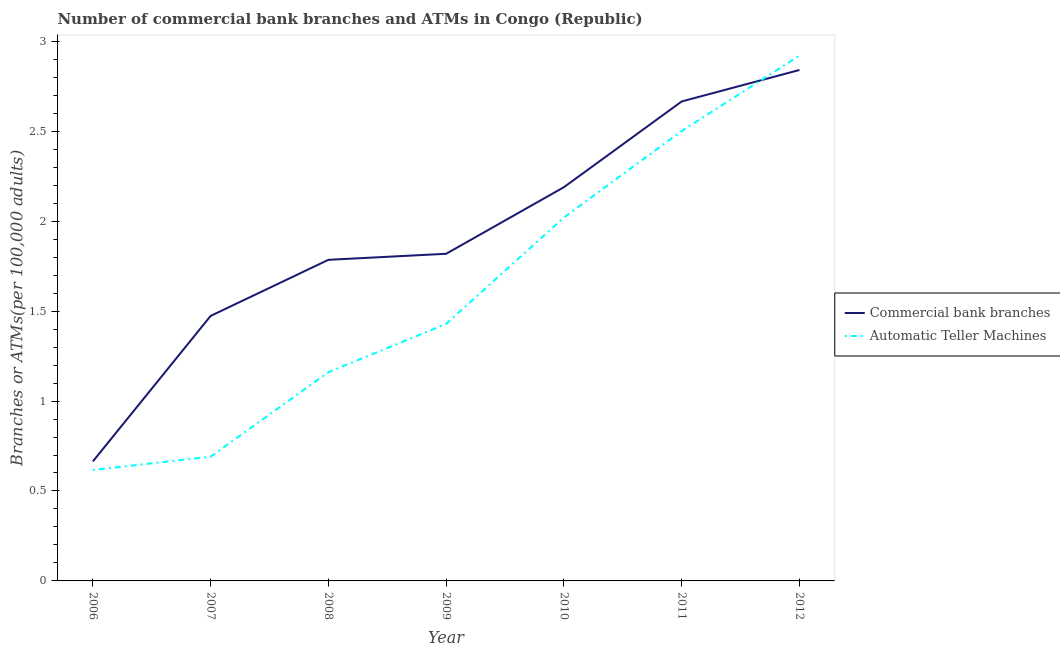Does the line corresponding to number of atms intersect with the line corresponding to number of commercal bank branches?
Provide a succinct answer. Yes. Is the number of lines equal to the number of legend labels?
Keep it short and to the point. Yes. What is the number of atms in 2008?
Ensure brevity in your answer.  1.16. Across all years, what is the maximum number of atms?
Keep it short and to the point. 2.92. Across all years, what is the minimum number of commercal bank branches?
Your response must be concise. 0.66. In which year was the number of commercal bank branches minimum?
Make the answer very short. 2006. What is the total number of atms in the graph?
Your response must be concise. 11.34. What is the difference between the number of atms in 2008 and that in 2010?
Give a very brief answer. -0.86. What is the difference between the number of atms in 2011 and the number of commercal bank branches in 2010?
Your answer should be compact. 0.31. What is the average number of atms per year?
Make the answer very short. 1.62. In the year 2008, what is the difference between the number of commercal bank branches and number of atms?
Offer a terse response. 0.62. In how many years, is the number of atms greater than 2.6?
Provide a succinct answer. 1. What is the ratio of the number of atms in 2008 to that in 2010?
Your answer should be compact. 0.57. Is the number of commercal bank branches in 2007 less than that in 2011?
Make the answer very short. Yes. What is the difference between the highest and the second highest number of commercal bank branches?
Make the answer very short. 0.18. What is the difference between the highest and the lowest number of atms?
Provide a succinct answer. 2.3. In how many years, is the number of commercal bank branches greater than the average number of commercal bank branches taken over all years?
Your answer should be compact. 3. Is the sum of the number of atms in 2006 and 2009 greater than the maximum number of commercal bank branches across all years?
Your answer should be very brief. No. Does the number of atms monotonically increase over the years?
Your answer should be very brief. Yes. Is the number of atms strictly greater than the number of commercal bank branches over the years?
Ensure brevity in your answer.  No. How many lines are there?
Keep it short and to the point. 2. How many years are there in the graph?
Your answer should be compact. 7. What is the difference between two consecutive major ticks on the Y-axis?
Provide a succinct answer. 0.5. Are the values on the major ticks of Y-axis written in scientific E-notation?
Make the answer very short. No. Does the graph contain any zero values?
Give a very brief answer. No. Where does the legend appear in the graph?
Provide a succinct answer. Center right. How many legend labels are there?
Give a very brief answer. 2. How are the legend labels stacked?
Offer a terse response. Vertical. What is the title of the graph?
Your answer should be very brief. Number of commercial bank branches and ATMs in Congo (Republic). Does "Fraud firms" appear as one of the legend labels in the graph?
Provide a succinct answer. No. What is the label or title of the X-axis?
Make the answer very short. Year. What is the label or title of the Y-axis?
Make the answer very short. Branches or ATMs(per 100,0 adults). What is the Branches or ATMs(per 100,000 adults) in Commercial bank branches in 2006?
Your answer should be compact. 0.66. What is the Branches or ATMs(per 100,000 adults) of Automatic Teller Machines in 2006?
Your answer should be very brief. 0.62. What is the Branches or ATMs(per 100,000 adults) in Commercial bank branches in 2007?
Ensure brevity in your answer.  1.47. What is the Branches or ATMs(per 100,000 adults) in Automatic Teller Machines in 2007?
Your answer should be very brief. 0.69. What is the Branches or ATMs(per 100,000 adults) in Commercial bank branches in 2008?
Offer a terse response. 1.79. What is the Branches or ATMs(per 100,000 adults) in Automatic Teller Machines in 2008?
Provide a short and direct response. 1.16. What is the Branches or ATMs(per 100,000 adults) in Commercial bank branches in 2009?
Ensure brevity in your answer.  1.82. What is the Branches or ATMs(per 100,000 adults) of Automatic Teller Machines in 2009?
Provide a succinct answer. 1.43. What is the Branches or ATMs(per 100,000 adults) in Commercial bank branches in 2010?
Provide a succinct answer. 2.19. What is the Branches or ATMs(per 100,000 adults) in Automatic Teller Machines in 2010?
Give a very brief answer. 2.02. What is the Branches or ATMs(per 100,000 adults) in Commercial bank branches in 2011?
Offer a very short reply. 2.67. What is the Branches or ATMs(per 100,000 adults) of Automatic Teller Machines in 2011?
Offer a terse response. 2.5. What is the Branches or ATMs(per 100,000 adults) of Commercial bank branches in 2012?
Ensure brevity in your answer.  2.84. What is the Branches or ATMs(per 100,000 adults) of Automatic Teller Machines in 2012?
Your answer should be compact. 2.92. Across all years, what is the maximum Branches or ATMs(per 100,000 adults) in Commercial bank branches?
Your response must be concise. 2.84. Across all years, what is the maximum Branches or ATMs(per 100,000 adults) of Automatic Teller Machines?
Your answer should be very brief. 2.92. Across all years, what is the minimum Branches or ATMs(per 100,000 adults) in Commercial bank branches?
Make the answer very short. 0.66. Across all years, what is the minimum Branches or ATMs(per 100,000 adults) in Automatic Teller Machines?
Your answer should be compact. 0.62. What is the total Branches or ATMs(per 100,000 adults) of Commercial bank branches in the graph?
Your answer should be very brief. 13.44. What is the total Branches or ATMs(per 100,000 adults) in Automatic Teller Machines in the graph?
Provide a short and direct response. 11.34. What is the difference between the Branches or ATMs(per 100,000 adults) in Commercial bank branches in 2006 and that in 2007?
Provide a short and direct response. -0.81. What is the difference between the Branches or ATMs(per 100,000 adults) of Automatic Teller Machines in 2006 and that in 2007?
Keep it short and to the point. -0.07. What is the difference between the Branches or ATMs(per 100,000 adults) of Commercial bank branches in 2006 and that in 2008?
Your answer should be compact. -1.12. What is the difference between the Branches or ATMs(per 100,000 adults) in Automatic Teller Machines in 2006 and that in 2008?
Ensure brevity in your answer.  -0.54. What is the difference between the Branches or ATMs(per 100,000 adults) in Commercial bank branches in 2006 and that in 2009?
Make the answer very short. -1.15. What is the difference between the Branches or ATMs(per 100,000 adults) in Automatic Teller Machines in 2006 and that in 2009?
Provide a succinct answer. -0.81. What is the difference between the Branches or ATMs(per 100,000 adults) in Commercial bank branches in 2006 and that in 2010?
Provide a short and direct response. -1.52. What is the difference between the Branches or ATMs(per 100,000 adults) in Automatic Teller Machines in 2006 and that in 2010?
Your response must be concise. -1.4. What is the difference between the Branches or ATMs(per 100,000 adults) of Commercial bank branches in 2006 and that in 2011?
Keep it short and to the point. -2. What is the difference between the Branches or ATMs(per 100,000 adults) in Automatic Teller Machines in 2006 and that in 2011?
Provide a short and direct response. -1.88. What is the difference between the Branches or ATMs(per 100,000 adults) of Commercial bank branches in 2006 and that in 2012?
Your response must be concise. -2.18. What is the difference between the Branches or ATMs(per 100,000 adults) in Automatic Teller Machines in 2006 and that in 2012?
Offer a very short reply. -2.3. What is the difference between the Branches or ATMs(per 100,000 adults) of Commercial bank branches in 2007 and that in 2008?
Your response must be concise. -0.31. What is the difference between the Branches or ATMs(per 100,000 adults) of Automatic Teller Machines in 2007 and that in 2008?
Keep it short and to the point. -0.47. What is the difference between the Branches or ATMs(per 100,000 adults) in Commercial bank branches in 2007 and that in 2009?
Ensure brevity in your answer.  -0.35. What is the difference between the Branches or ATMs(per 100,000 adults) in Automatic Teller Machines in 2007 and that in 2009?
Your response must be concise. -0.74. What is the difference between the Branches or ATMs(per 100,000 adults) in Commercial bank branches in 2007 and that in 2010?
Your answer should be compact. -0.72. What is the difference between the Branches or ATMs(per 100,000 adults) in Automatic Teller Machines in 2007 and that in 2010?
Your answer should be compact. -1.33. What is the difference between the Branches or ATMs(per 100,000 adults) in Commercial bank branches in 2007 and that in 2011?
Keep it short and to the point. -1.19. What is the difference between the Branches or ATMs(per 100,000 adults) in Automatic Teller Machines in 2007 and that in 2011?
Your answer should be very brief. -1.81. What is the difference between the Branches or ATMs(per 100,000 adults) of Commercial bank branches in 2007 and that in 2012?
Provide a succinct answer. -1.37. What is the difference between the Branches or ATMs(per 100,000 adults) of Automatic Teller Machines in 2007 and that in 2012?
Make the answer very short. -2.23. What is the difference between the Branches or ATMs(per 100,000 adults) of Commercial bank branches in 2008 and that in 2009?
Provide a succinct answer. -0.03. What is the difference between the Branches or ATMs(per 100,000 adults) of Automatic Teller Machines in 2008 and that in 2009?
Your answer should be compact. -0.27. What is the difference between the Branches or ATMs(per 100,000 adults) of Commercial bank branches in 2008 and that in 2010?
Keep it short and to the point. -0.4. What is the difference between the Branches or ATMs(per 100,000 adults) of Automatic Teller Machines in 2008 and that in 2010?
Provide a short and direct response. -0.86. What is the difference between the Branches or ATMs(per 100,000 adults) of Commercial bank branches in 2008 and that in 2011?
Provide a short and direct response. -0.88. What is the difference between the Branches or ATMs(per 100,000 adults) of Automatic Teller Machines in 2008 and that in 2011?
Your answer should be very brief. -1.34. What is the difference between the Branches or ATMs(per 100,000 adults) of Commercial bank branches in 2008 and that in 2012?
Your answer should be compact. -1.06. What is the difference between the Branches or ATMs(per 100,000 adults) in Automatic Teller Machines in 2008 and that in 2012?
Your response must be concise. -1.76. What is the difference between the Branches or ATMs(per 100,000 adults) of Commercial bank branches in 2009 and that in 2010?
Offer a terse response. -0.37. What is the difference between the Branches or ATMs(per 100,000 adults) in Automatic Teller Machines in 2009 and that in 2010?
Offer a very short reply. -0.59. What is the difference between the Branches or ATMs(per 100,000 adults) of Commercial bank branches in 2009 and that in 2011?
Provide a succinct answer. -0.85. What is the difference between the Branches or ATMs(per 100,000 adults) in Automatic Teller Machines in 2009 and that in 2011?
Your answer should be very brief. -1.07. What is the difference between the Branches or ATMs(per 100,000 adults) of Commercial bank branches in 2009 and that in 2012?
Your answer should be compact. -1.02. What is the difference between the Branches or ATMs(per 100,000 adults) of Automatic Teller Machines in 2009 and that in 2012?
Ensure brevity in your answer.  -1.49. What is the difference between the Branches or ATMs(per 100,000 adults) in Commercial bank branches in 2010 and that in 2011?
Offer a terse response. -0.48. What is the difference between the Branches or ATMs(per 100,000 adults) in Automatic Teller Machines in 2010 and that in 2011?
Offer a terse response. -0.48. What is the difference between the Branches or ATMs(per 100,000 adults) in Commercial bank branches in 2010 and that in 2012?
Provide a succinct answer. -0.65. What is the difference between the Branches or ATMs(per 100,000 adults) in Automatic Teller Machines in 2010 and that in 2012?
Provide a short and direct response. -0.9. What is the difference between the Branches or ATMs(per 100,000 adults) of Commercial bank branches in 2011 and that in 2012?
Give a very brief answer. -0.17. What is the difference between the Branches or ATMs(per 100,000 adults) in Automatic Teller Machines in 2011 and that in 2012?
Your answer should be very brief. -0.42. What is the difference between the Branches or ATMs(per 100,000 adults) of Commercial bank branches in 2006 and the Branches or ATMs(per 100,000 adults) of Automatic Teller Machines in 2007?
Your response must be concise. -0.03. What is the difference between the Branches or ATMs(per 100,000 adults) of Commercial bank branches in 2006 and the Branches or ATMs(per 100,000 adults) of Automatic Teller Machines in 2008?
Keep it short and to the point. -0.5. What is the difference between the Branches or ATMs(per 100,000 adults) in Commercial bank branches in 2006 and the Branches or ATMs(per 100,000 adults) in Automatic Teller Machines in 2009?
Keep it short and to the point. -0.76. What is the difference between the Branches or ATMs(per 100,000 adults) in Commercial bank branches in 2006 and the Branches or ATMs(per 100,000 adults) in Automatic Teller Machines in 2010?
Your response must be concise. -1.36. What is the difference between the Branches or ATMs(per 100,000 adults) of Commercial bank branches in 2006 and the Branches or ATMs(per 100,000 adults) of Automatic Teller Machines in 2011?
Your response must be concise. -1.84. What is the difference between the Branches or ATMs(per 100,000 adults) of Commercial bank branches in 2006 and the Branches or ATMs(per 100,000 adults) of Automatic Teller Machines in 2012?
Provide a short and direct response. -2.26. What is the difference between the Branches or ATMs(per 100,000 adults) in Commercial bank branches in 2007 and the Branches or ATMs(per 100,000 adults) in Automatic Teller Machines in 2008?
Provide a short and direct response. 0.31. What is the difference between the Branches or ATMs(per 100,000 adults) in Commercial bank branches in 2007 and the Branches or ATMs(per 100,000 adults) in Automatic Teller Machines in 2009?
Give a very brief answer. 0.04. What is the difference between the Branches or ATMs(per 100,000 adults) of Commercial bank branches in 2007 and the Branches or ATMs(per 100,000 adults) of Automatic Teller Machines in 2010?
Your response must be concise. -0.55. What is the difference between the Branches or ATMs(per 100,000 adults) of Commercial bank branches in 2007 and the Branches or ATMs(per 100,000 adults) of Automatic Teller Machines in 2011?
Your answer should be compact. -1.03. What is the difference between the Branches or ATMs(per 100,000 adults) of Commercial bank branches in 2007 and the Branches or ATMs(per 100,000 adults) of Automatic Teller Machines in 2012?
Ensure brevity in your answer.  -1.45. What is the difference between the Branches or ATMs(per 100,000 adults) of Commercial bank branches in 2008 and the Branches or ATMs(per 100,000 adults) of Automatic Teller Machines in 2009?
Your answer should be very brief. 0.36. What is the difference between the Branches or ATMs(per 100,000 adults) of Commercial bank branches in 2008 and the Branches or ATMs(per 100,000 adults) of Automatic Teller Machines in 2010?
Offer a very short reply. -0.24. What is the difference between the Branches or ATMs(per 100,000 adults) of Commercial bank branches in 2008 and the Branches or ATMs(per 100,000 adults) of Automatic Teller Machines in 2011?
Your answer should be very brief. -0.72. What is the difference between the Branches or ATMs(per 100,000 adults) of Commercial bank branches in 2008 and the Branches or ATMs(per 100,000 adults) of Automatic Teller Machines in 2012?
Keep it short and to the point. -1.14. What is the difference between the Branches or ATMs(per 100,000 adults) in Commercial bank branches in 2009 and the Branches or ATMs(per 100,000 adults) in Automatic Teller Machines in 2010?
Offer a very short reply. -0.2. What is the difference between the Branches or ATMs(per 100,000 adults) of Commercial bank branches in 2009 and the Branches or ATMs(per 100,000 adults) of Automatic Teller Machines in 2011?
Your answer should be very brief. -0.68. What is the difference between the Branches or ATMs(per 100,000 adults) in Commercial bank branches in 2009 and the Branches or ATMs(per 100,000 adults) in Automatic Teller Machines in 2012?
Your answer should be compact. -1.1. What is the difference between the Branches or ATMs(per 100,000 adults) of Commercial bank branches in 2010 and the Branches or ATMs(per 100,000 adults) of Automatic Teller Machines in 2011?
Offer a terse response. -0.31. What is the difference between the Branches or ATMs(per 100,000 adults) in Commercial bank branches in 2010 and the Branches or ATMs(per 100,000 adults) in Automatic Teller Machines in 2012?
Offer a very short reply. -0.73. What is the difference between the Branches or ATMs(per 100,000 adults) of Commercial bank branches in 2011 and the Branches or ATMs(per 100,000 adults) of Automatic Teller Machines in 2012?
Provide a short and direct response. -0.26. What is the average Branches or ATMs(per 100,000 adults) in Commercial bank branches per year?
Provide a succinct answer. 1.92. What is the average Branches or ATMs(per 100,000 adults) of Automatic Teller Machines per year?
Provide a succinct answer. 1.62. In the year 2006, what is the difference between the Branches or ATMs(per 100,000 adults) in Commercial bank branches and Branches or ATMs(per 100,000 adults) in Automatic Teller Machines?
Keep it short and to the point. 0.05. In the year 2007, what is the difference between the Branches or ATMs(per 100,000 adults) of Commercial bank branches and Branches or ATMs(per 100,000 adults) of Automatic Teller Machines?
Give a very brief answer. 0.78. In the year 2008, what is the difference between the Branches or ATMs(per 100,000 adults) in Commercial bank branches and Branches or ATMs(per 100,000 adults) in Automatic Teller Machines?
Offer a very short reply. 0.62. In the year 2009, what is the difference between the Branches or ATMs(per 100,000 adults) in Commercial bank branches and Branches or ATMs(per 100,000 adults) in Automatic Teller Machines?
Give a very brief answer. 0.39. In the year 2010, what is the difference between the Branches or ATMs(per 100,000 adults) of Commercial bank branches and Branches or ATMs(per 100,000 adults) of Automatic Teller Machines?
Give a very brief answer. 0.17. In the year 2011, what is the difference between the Branches or ATMs(per 100,000 adults) of Commercial bank branches and Branches or ATMs(per 100,000 adults) of Automatic Teller Machines?
Give a very brief answer. 0.16. In the year 2012, what is the difference between the Branches or ATMs(per 100,000 adults) of Commercial bank branches and Branches or ATMs(per 100,000 adults) of Automatic Teller Machines?
Give a very brief answer. -0.08. What is the ratio of the Branches or ATMs(per 100,000 adults) in Commercial bank branches in 2006 to that in 2007?
Ensure brevity in your answer.  0.45. What is the ratio of the Branches or ATMs(per 100,000 adults) in Automatic Teller Machines in 2006 to that in 2007?
Provide a succinct answer. 0.89. What is the ratio of the Branches or ATMs(per 100,000 adults) in Commercial bank branches in 2006 to that in 2008?
Provide a succinct answer. 0.37. What is the ratio of the Branches or ATMs(per 100,000 adults) of Automatic Teller Machines in 2006 to that in 2008?
Offer a very short reply. 0.53. What is the ratio of the Branches or ATMs(per 100,000 adults) of Commercial bank branches in 2006 to that in 2009?
Give a very brief answer. 0.37. What is the ratio of the Branches or ATMs(per 100,000 adults) of Automatic Teller Machines in 2006 to that in 2009?
Your answer should be very brief. 0.43. What is the ratio of the Branches or ATMs(per 100,000 adults) in Commercial bank branches in 2006 to that in 2010?
Offer a very short reply. 0.3. What is the ratio of the Branches or ATMs(per 100,000 adults) of Automatic Teller Machines in 2006 to that in 2010?
Ensure brevity in your answer.  0.31. What is the ratio of the Branches or ATMs(per 100,000 adults) of Commercial bank branches in 2006 to that in 2011?
Keep it short and to the point. 0.25. What is the ratio of the Branches or ATMs(per 100,000 adults) in Automatic Teller Machines in 2006 to that in 2011?
Make the answer very short. 0.25. What is the ratio of the Branches or ATMs(per 100,000 adults) of Commercial bank branches in 2006 to that in 2012?
Keep it short and to the point. 0.23. What is the ratio of the Branches or ATMs(per 100,000 adults) of Automatic Teller Machines in 2006 to that in 2012?
Give a very brief answer. 0.21. What is the ratio of the Branches or ATMs(per 100,000 adults) of Commercial bank branches in 2007 to that in 2008?
Your answer should be compact. 0.83. What is the ratio of the Branches or ATMs(per 100,000 adults) of Automatic Teller Machines in 2007 to that in 2008?
Provide a short and direct response. 0.6. What is the ratio of the Branches or ATMs(per 100,000 adults) in Commercial bank branches in 2007 to that in 2009?
Ensure brevity in your answer.  0.81. What is the ratio of the Branches or ATMs(per 100,000 adults) of Automatic Teller Machines in 2007 to that in 2009?
Offer a terse response. 0.48. What is the ratio of the Branches or ATMs(per 100,000 adults) in Commercial bank branches in 2007 to that in 2010?
Keep it short and to the point. 0.67. What is the ratio of the Branches or ATMs(per 100,000 adults) in Automatic Teller Machines in 2007 to that in 2010?
Your response must be concise. 0.34. What is the ratio of the Branches or ATMs(per 100,000 adults) in Commercial bank branches in 2007 to that in 2011?
Provide a succinct answer. 0.55. What is the ratio of the Branches or ATMs(per 100,000 adults) of Automatic Teller Machines in 2007 to that in 2011?
Your answer should be compact. 0.28. What is the ratio of the Branches or ATMs(per 100,000 adults) in Commercial bank branches in 2007 to that in 2012?
Offer a very short reply. 0.52. What is the ratio of the Branches or ATMs(per 100,000 adults) in Automatic Teller Machines in 2007 to that in 2012?
Offer a terse response. 0.24. What is the ratio of the Branches or ATMs(per 100,000 adults) in Commercial bank branches in 2008 to that in 2009?
Provide a succinct answer. 0.98. What is the ratio of the Branches or ATMs(per 100,000 adults) of Automatic Teller Machines in 2008 to that in 2009?
Your answer should be very brief. 0.81. What is the ratio of the Branches or ATMs(per 100,000 adults) in Commercial bank branches in 2008 to that in 2010?
Your response must be concise. 0.82. What is the ratio of the Branches or ATMs(per 100,000 adults) in Automatic Teller Machines in 2008 to that in 2010?
Offer a very short reply. 0.57. What is the ratio of the Branches or ATMs(per 100,000 adults) in Commercial bank branches in 2008 to that in 2011?
Provide a short and direct response. 0.67. What is the ratio of the Branches or ATMs(per 100,000 adults) in Automatic Teller Machines in 2008 to that in 2011?
Keep it short and to the point. 0.46. What is the ratio of the Branches or ATMs(per 100,000 adults) in Commercial bank branches in 2008 to that in 2012?
Your answer should be very brief. 0.63. What is the ratio of the Branches or ATMs(per 100,000 adults) in Automatic Teller Machines in 2008 to that in 2012?
Ensure brevity in your answer.  0.4. What is the ratio of the Branches or ATMs(per 100,000 adults) of Commercial bank branches in 2009 to that in 2010?
Offer a very short reply. 0.83. What is the ratio of the Branches or ATMs(per 100,000 adults) in Automatic Teller Machines in 2009 to that in 2010?
Offer a terse response. 0.71. What is the ratio of the Branches or ATMs(per 100,000 adults) in Commercial bank branches in 2009 to that in 2011?
Offer a very short reply. 0.68. What is the ratio of the Branches or ATMs(per 100,000 adults) in Automatic Teller Machines in 2009 to that in 2011?
Your response must be concise. 0.57. What is the ratio of the Branches or ATMs(per 100,000 adults) in Commercial bank branches in 2009 to that in 2012?
Your response must be concise. 0.64. What is the ratio of the Branches or ATMs(per 100,000 adults) in Automatic Teller Machines in 2009 to that in 2012?
Your answer should be compact. 0.49. What is the ratio of the Branches or ATMs(per 100,000 adults) of Commercial bank branches in 2010 to that in 2011?
Your answer should be compact. 0.82. What is the ratio of the Branches or ATMs(per 100,000 adults) in Automatic Teller Machines in 2010 to that in 2011?
Make the answer very short. 0.81. What is the ratio of the Branches or ATMs(per 100,000 adults) of Commercial bank branches in 2010 to that in 2012?
Ensure brevity in your answer.  0.77. What is the ratio of the Branches or ATMs(per 100,000 adults) in Automatic Teller Machines in 2010 to that in 2012?
Your answer should be compact. 0.69. What is the ratio of the Branches or ATMs(per 100,000 adults) of Commercial bank branches in 2011 to that in 2012?
Make the answer very short. 0.94. What is the ratio of the Branches or ATMs(per 100,000 adults) in Automatic Teller Machines in 2011 to that in 2012?
Your response must be concise. 0.86. What is the difference between the highest and the second highest Branches or ATMs(per 100,000 adults) of Commercial bank branches?
Your answer should be compact. 0.17. What is the difference between the highest and the second highest Branches or ATMs(per 100,000 adults) of Automatic Teller Machines?
Provide a short and direct response. 0.42. What is the difference between the highest and the lowest Branches or ATMs(per 100,000 adults) in Commercial bank branches?
Your answer should be very brief. 2.18. What is the difference between the highest and the lowest Branches or ATMs(per 100,000 adults) in Automatic Teller Machines?
Your answer should be very brief. 2.3. 